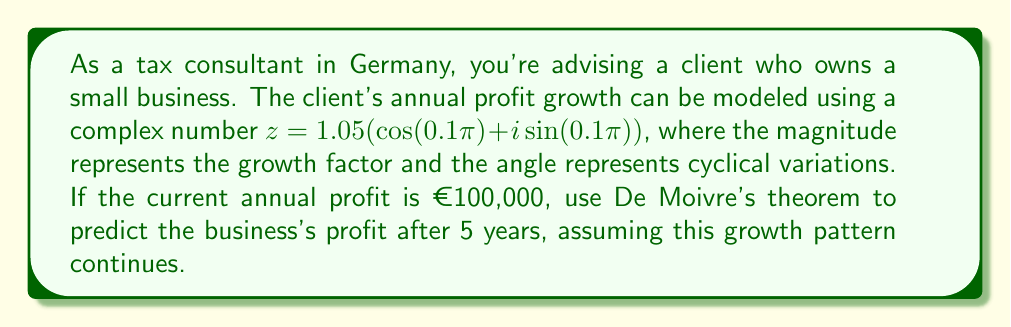Give your solution to this math problem. To solve this problem, we'll use De Moivre's theorem and follow these steps:

1) De Moivre's theorem states that for any complex number in polar form $r(\cos(\theta) + i\sin(\theta))$ and any integer $n$:

   $$(r(\cos(\theta) + i\sin(\theta)))^n = r^n(\cos(n\theta) + i\sin(n\theta))$$

2) In our case:
   $r = 1.05$ (growth factor)
   $\theta = 0.1\pi$ (cyclical variation)
   $n = 5$ (years)

3) We need to calculate $z^5$:

   $$z^5 = (1.05(\cos(0.1\pi) + i\sin(0.1\pi)))^5$$

4) Applying De Moivre's theorem:

   $$z^5 = 1.05^5(\cos(5 \cdot 0.1\pi) + i\sin(5 \cdot 0.1\pi))$$

5) Simplify:
   $$z^5 = 1.05^5(\cos(0.5\pi) + i\sin(0.5\pi))$$

6) Calculate $1.05^5$:
   $$1.05^5 \approx 1.2762815625$$

7) We know that $\cos(0.5\pi) = 0$ and $\sin(0.5\pi) = 1$, so:

   $$z^5 \approx 1.2762815625(0 + i)$$

8) The magnitude of this complex number represents the total growth factor over 5 years:

   $$|z^5| \approx 1.2762815625$$

9) To get the profit after 5 years, multiply the current profit by this factor:

   $$100,000 \cdot 1.2762815625 \approx 127,628.16$$

Therefore, the predicted profit after 5 years is approximately €127,628.16.
Answer: €127,628.16 